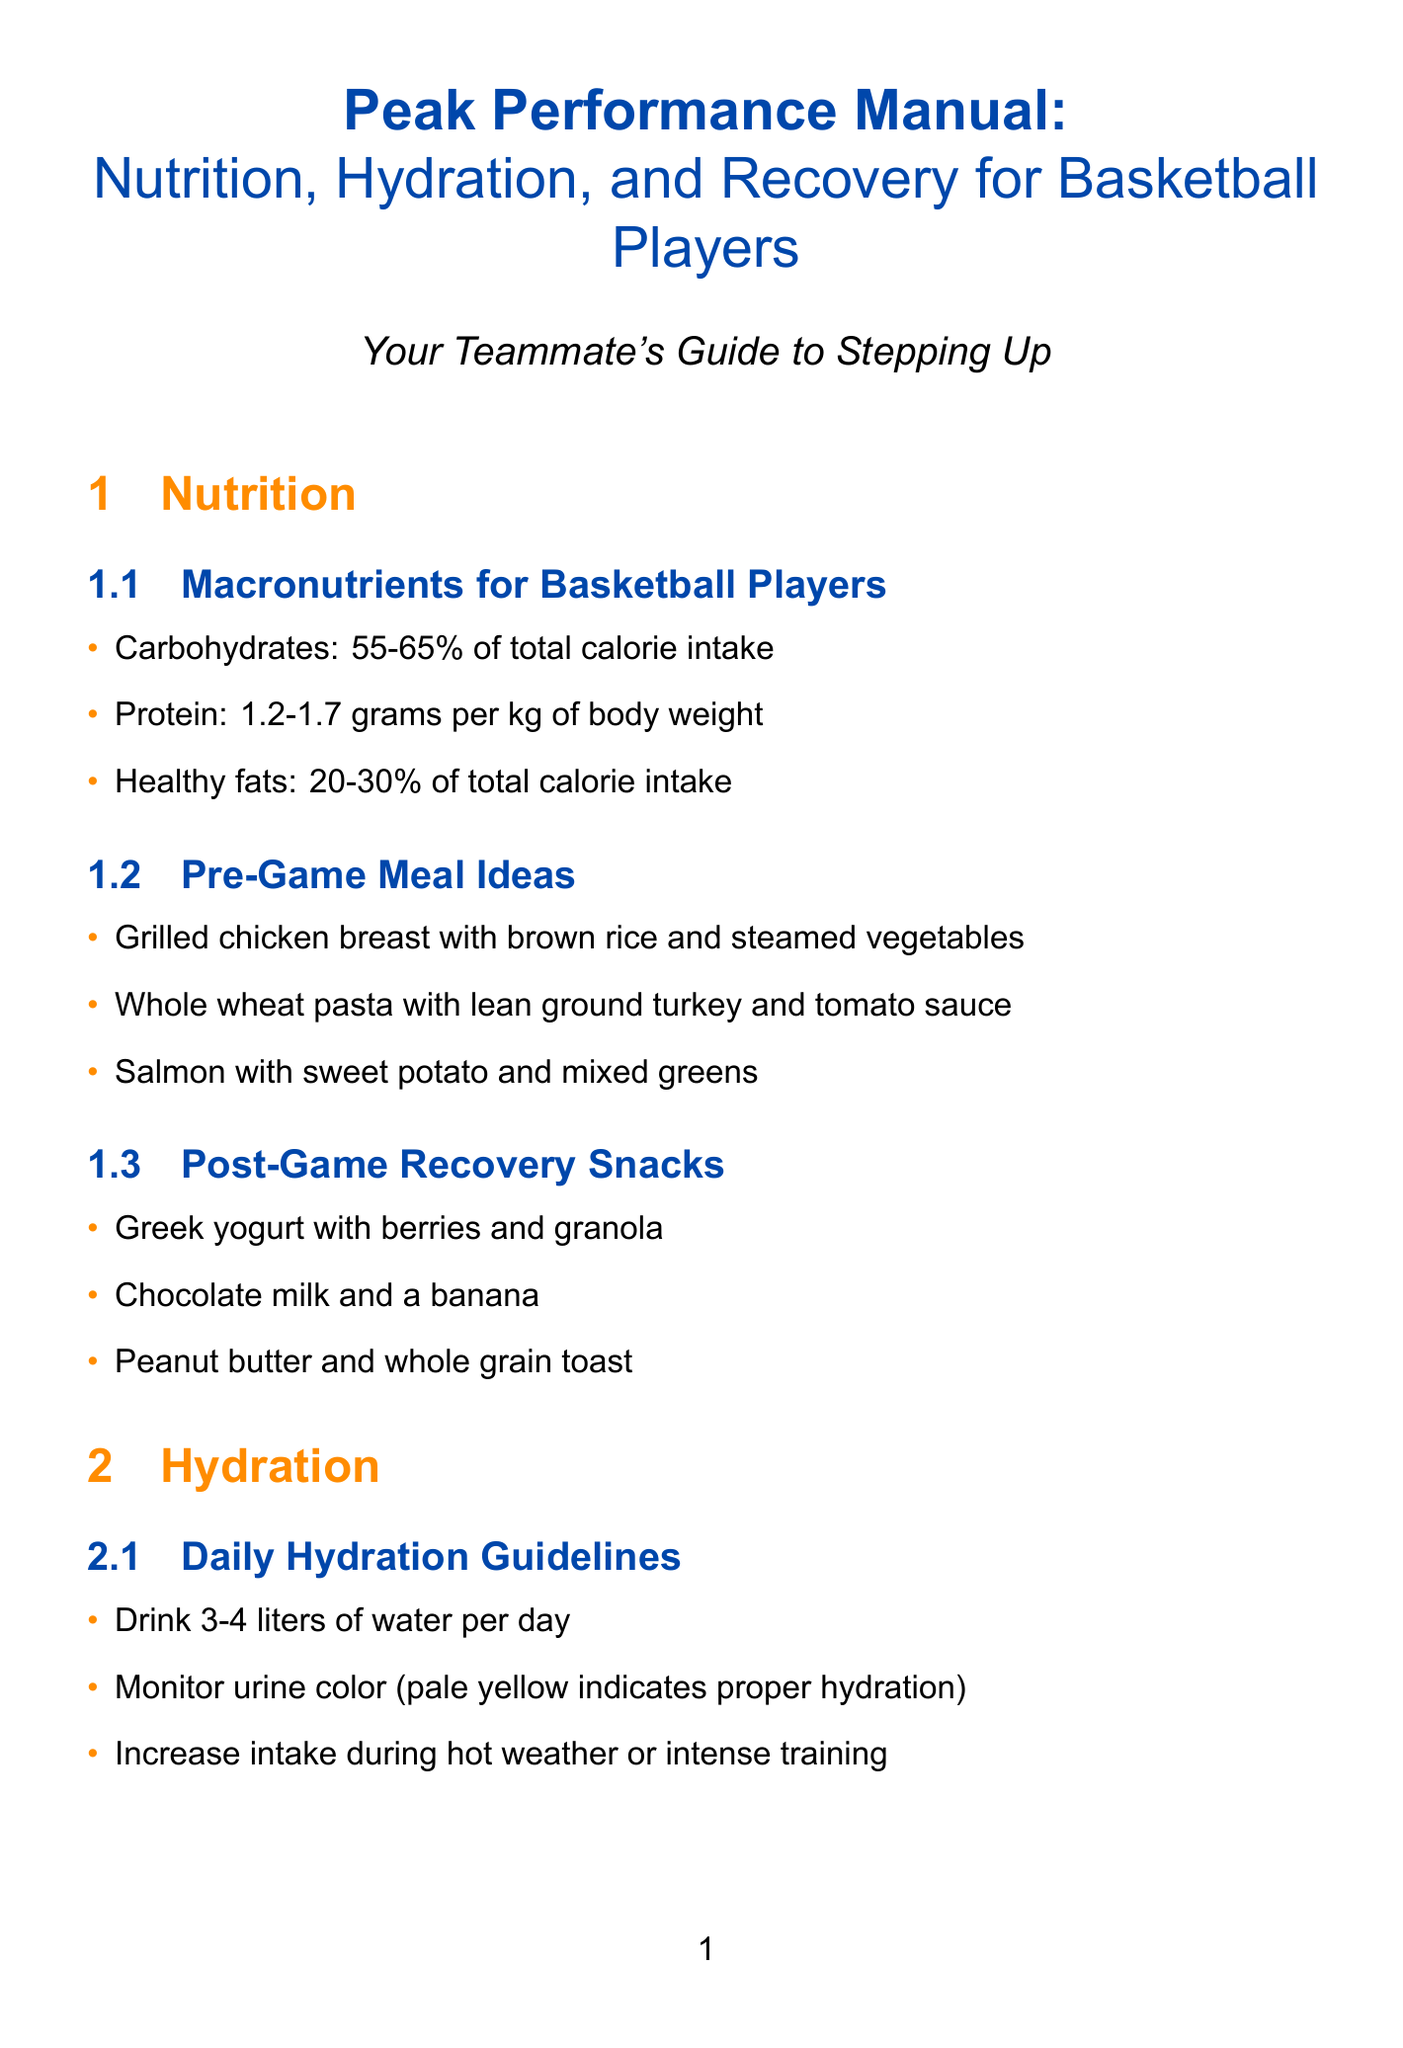what percentage of total calorie intake should carbohydrates represent for basketball players? The document states that carbohydrates should represent 55-65% of total calorie intake for basketball players.
Answer: 55-65% how many hours of sleep should basketball players aim for each night? According to the document, basketball players should aim for 8-10 hours of sleep per night.
Answer: 8-10 hours what is a recommended pre-game meal? The document lists grilled chicken breast with brown rice and steamed vegetables as a recommended pre-game meal.
Answer: Grilled chicken breast with brown rice and steamed vegetables what type of drink is suggested during intense games for electrolyte replenishment? The document suggests using sports drinks like Gatorade or Powerade during intense games for electrolyte replenishment.
Answer: Gatorade or Powerade how many liters of water should basketball players drink daily? The document recommends that basketball players drink 3-4 liters of water per day.
Answer: 3-4 liters what is the main purpose of ice baths according to the manual? Ice baths are primarily used for recovery after intense games, specifically for their cooling effects.
Answer: Recovery after intense games what should players consume to rehydrate after a game? The document mentions that players should rehydrate with 16-24 oz of fluid for every pound lost after the game.
Answer: 16-24 oz per pound lost which exercise is recommended for knee stability? The document lists single-leg squats as an exercise for knee stability.
Answer: Single-leg squats what is an optional supplement mentioned in the document? The document lists beta-alanine as an optional supplement for improved endurance.
Answer: Beta-alanine 